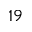<formula> <loc_0><loc_0><loc_500><loc_500>^ { 1 9 }</formula> 